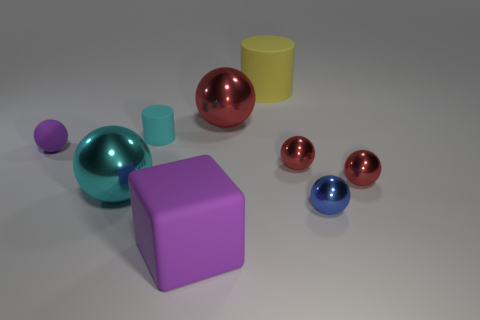How many red spheres must be subtracted to get 1 red spheres? 2 Subtract all gray cubes. How many red spheres are left? 3 Subtract 3 spheres. How many spheres are left? 3 Subtract all cyan spheres. How many spheres are left? 5 Subtract all small red balls. How many balls are left? 4 Subtract all yellow spheres. Subtract all red cylinders. How many spheres are left? 6 Subtract all spheres. How many objects are left? 3 Subtract all small red metal spheres. Subtract all tiny matte things. How many objects are left? 5 Add 4 tiny matte cylinders. How many tiny matte cylinders are left? 5 Add 6 cyan cylinders. How many cyan cylinders exist? 7 